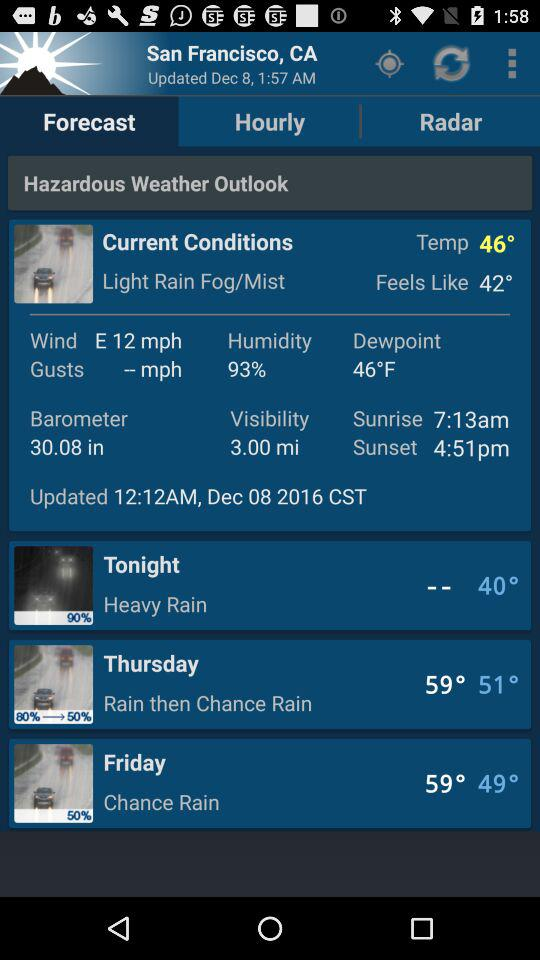What is the date? The date is December 8, 2016 CST. 